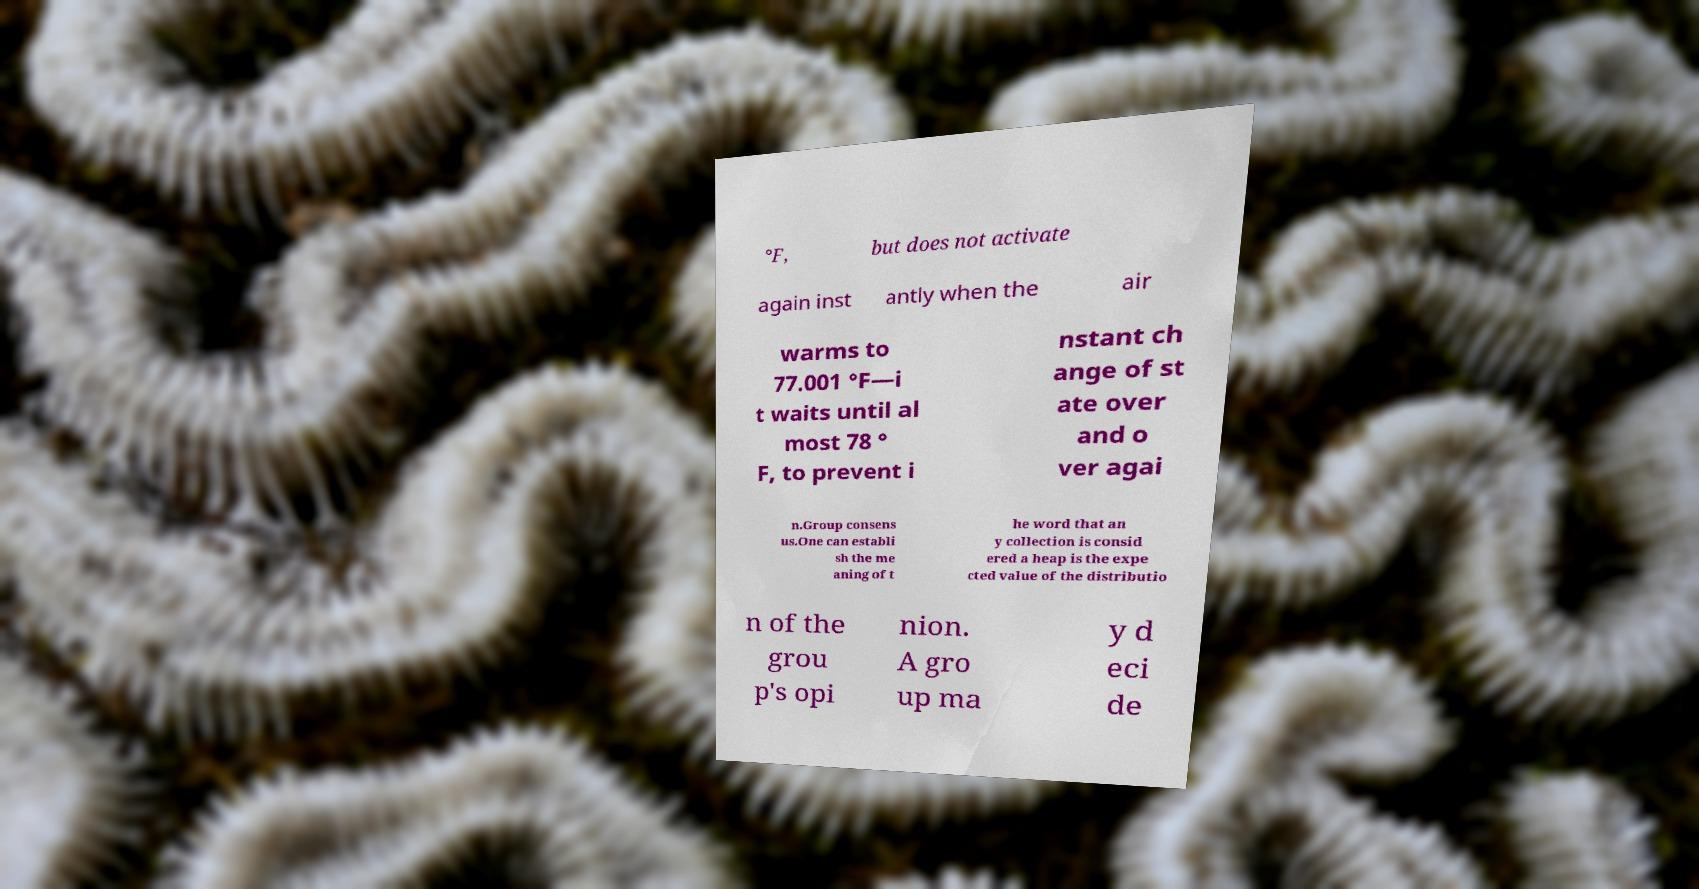Can you accurately transcribe the text from the provided image for me? °F, but does not activate again inst antly when the air warms to 77.001 °F—i t waits until al most 78 ° F, to prevent i nstant ch ange of st ate over and o ver agai n.Group consens us.One can establi sh the me aning of t he word that an y collection is consid ered a heap is the expe cted value of the distributio n of the grou p's opi nion. A gro up ma y d eci de 